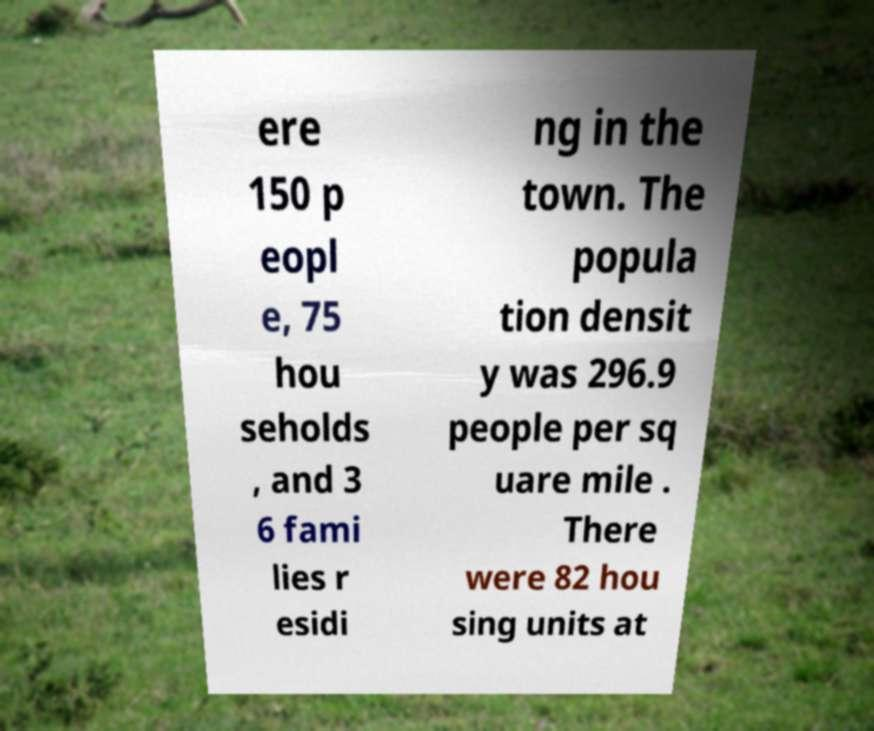Could you extract and type out the text from this image? ere 150 p eopl e, 75 hou seholds , and 3 6 fami lies r esidi ng in the town. The popula tion densit y was 296.9 people per sq uare mile . There were 82 hou sing units at 